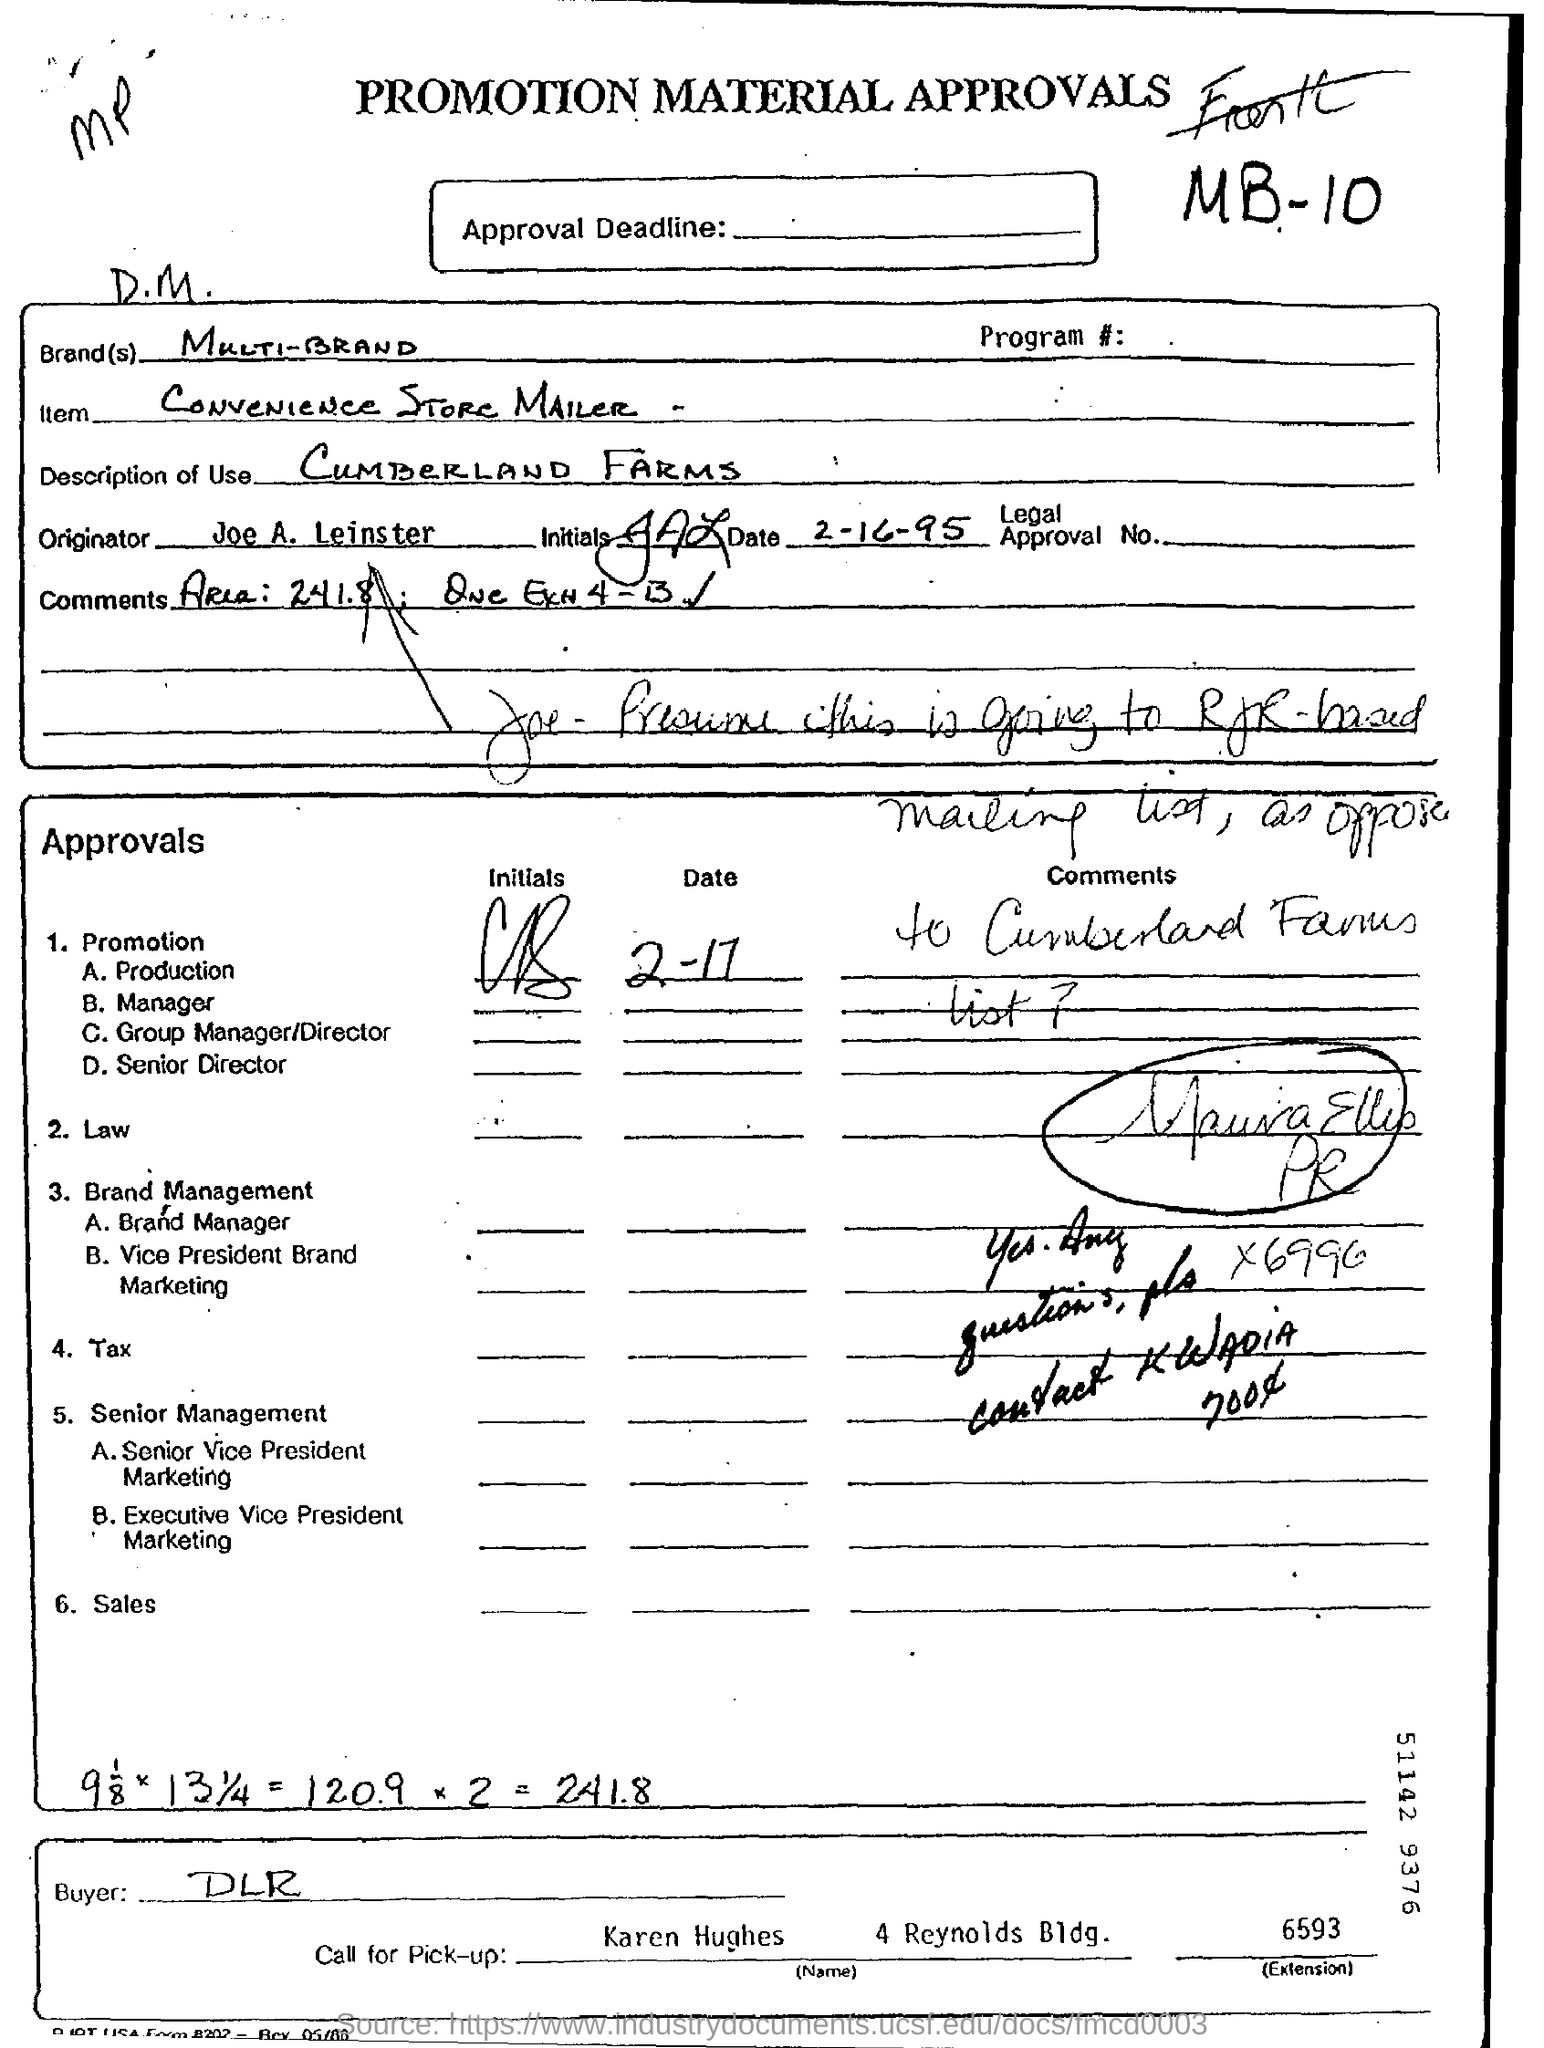Outline some significant characteristics in this image. Multi-brand approval is given here. This is a document that is classified as a promotion material approvals. The item mentioned in this document is a convenience store mailer. 